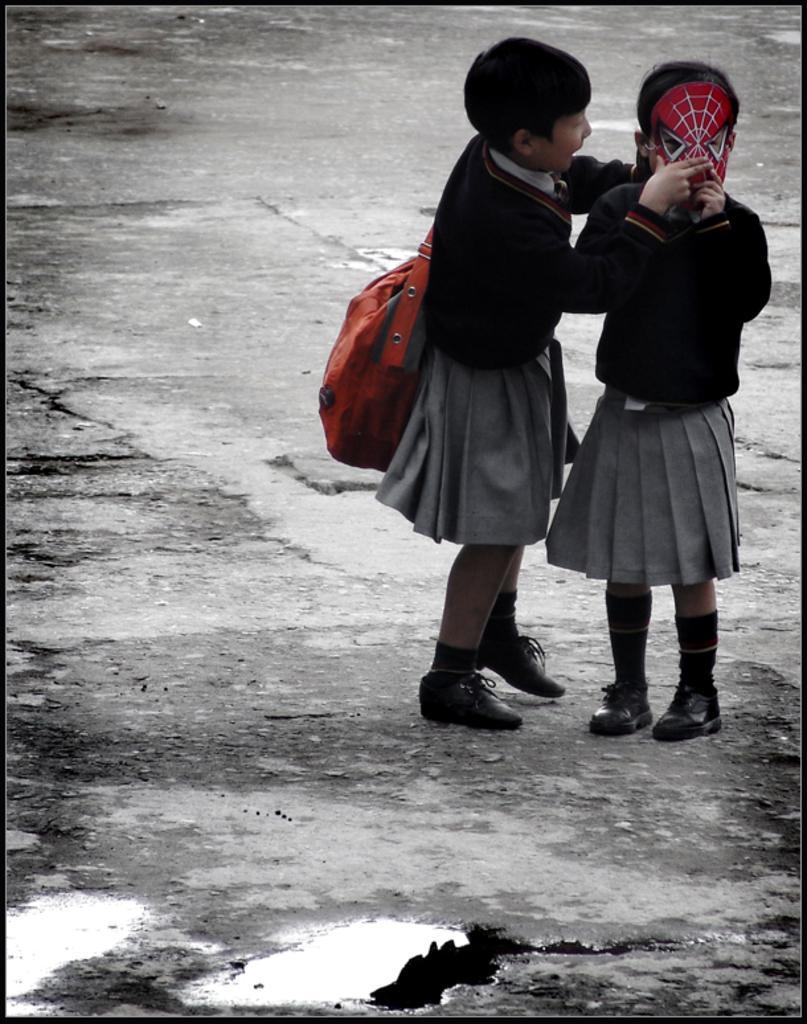Please provide a concise description of this image. In this image we can see two children. One child is wearing a face mask, another child is carrying a bag. 